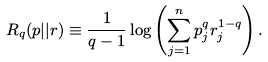Convert formula to latex. <formula><loc_0><loc_0><loc_500><loc_500>R _ { q } ( p | | r ) \equiv \frac { 1 } { q - 1 } \log \left ( \sum _ { j = 1 } ^ { n } p _ { j } ^ { q } r _ { j } ^ { 1 - q } \right ) .</formula> 